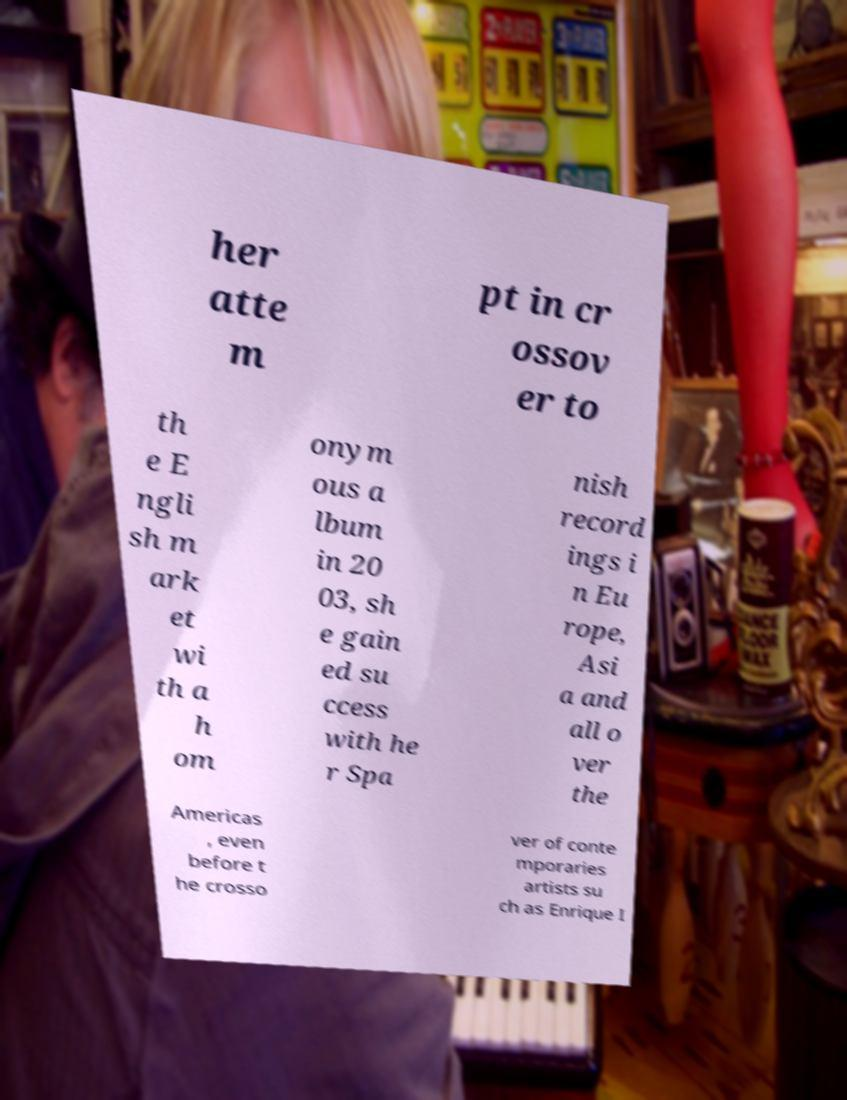Could you assist in decoding the text presented in this image and type it out clearly? her atte m pt in cr ossov er to th e E ngli sh m ark et wi th a h om onym ous a lbum in 20 03, sh e gain ed su ccess with he r Spa nish record ings i n Eu rope, Asi a and all o ver the Americas , even before t he crosso ver of conte mporaries artists su ch as Enrique I 